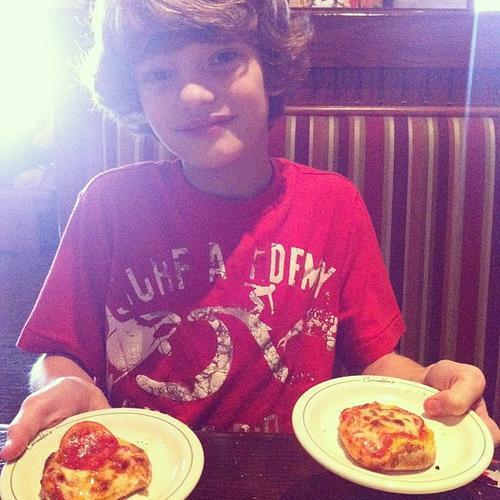How many plates is the boy holding?
Give a very brief answer. 2. How many children are in the picture?
Give a very brief answer. 1. How many dogs are in the picture?
Give a very brief answer. 0. 